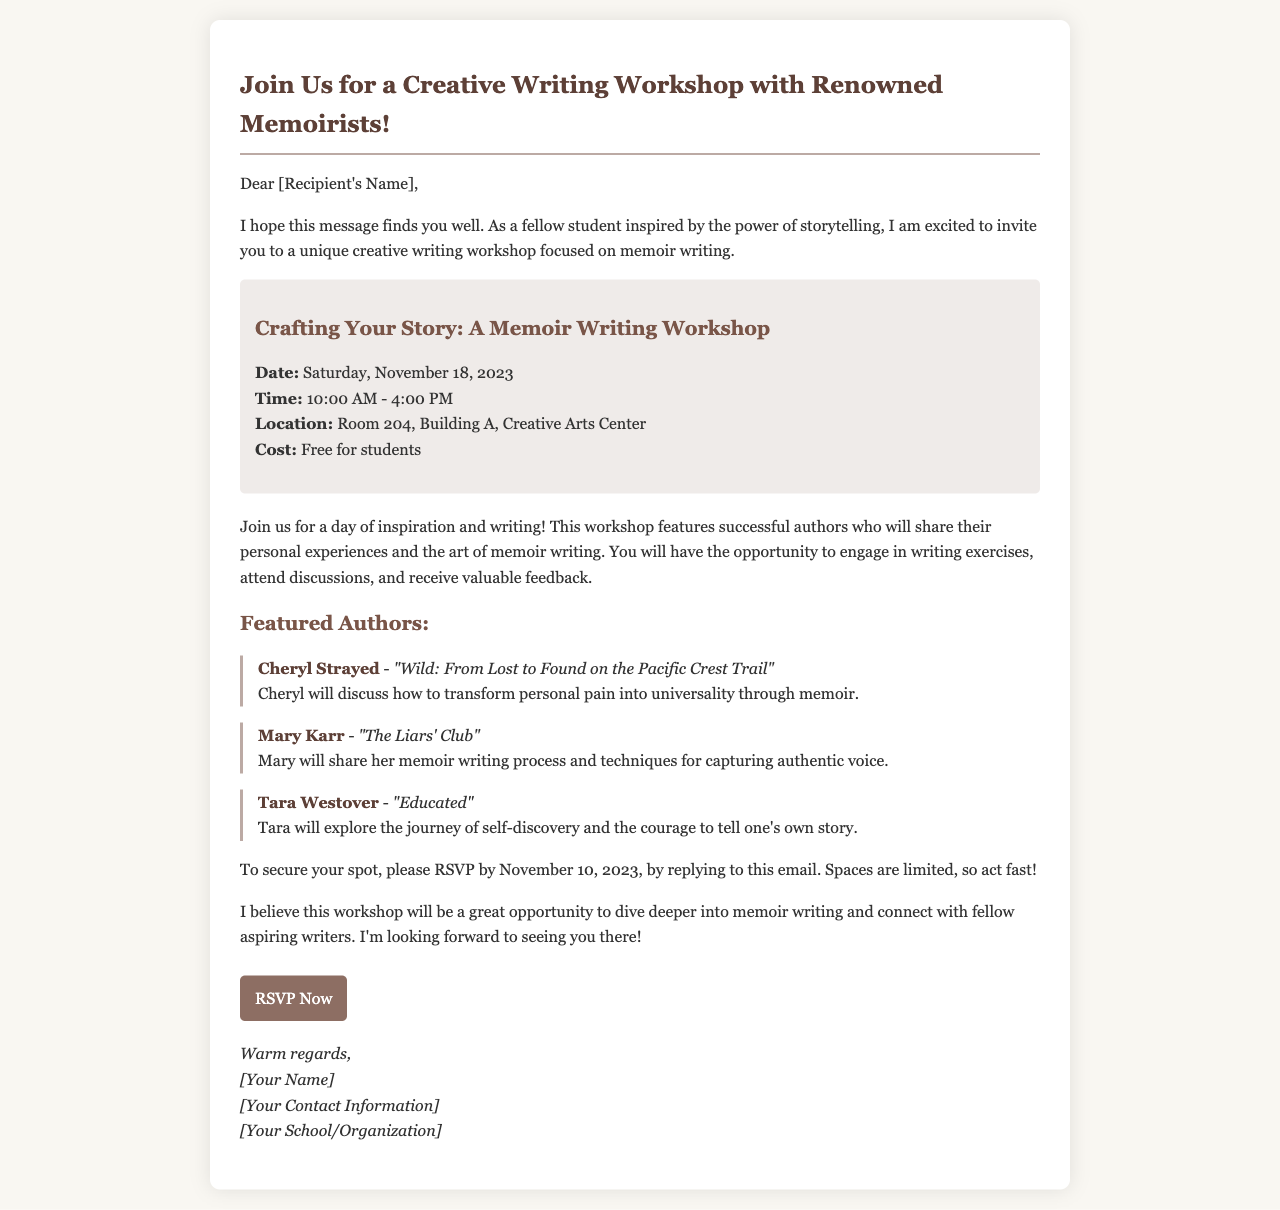what is the date of the workshop? The date of the workshop is explicitly mentioned in the event details section of the document.
Answer: Saturday, November 18, 2023 what is the location of the workshop? The location is specified in the event details, indicating where the workshop will take place.
Answer: Room 204, Building A, Creative Arts Center who is one of the featured authors? The document lists three authors as featured for the workshop, making this a retrieval question.
Answer: Cheryl Strayed how much does it cost to attend the workshop? The cost for students to attend the workshop is clearly stated in the event details section.
Answer: Free for students what is the RSVP deadline? The deadline for RSVPing is provided in the last part of the event details and is critical for attendance.
Answer: November 10, 2023 what type of writing will the workshop focus on? The workshop is specifically focused on a genre of writing mentioned in the introductory paragraph.
Answer: Memoir writing how long is the workshop scheduled to last? The time span of the workshop is noted, indicating the duration of the event.
Answer: 6 hours what will participants have the opportunity to receive? This refers to a benefit of attending the workshop mentioned in the document.
Answer: Valuable feedback 